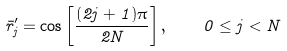Convert formula to latex. <formula><loc_0><loc_0><loc_500><loc_500>\bar { r } ^ { \prime } _ { j } = \cos \left [ \frac { ( 2 j + 1 ) \pi } { 2 N } \right ] , \quad 0 \leq j < N</formula> 